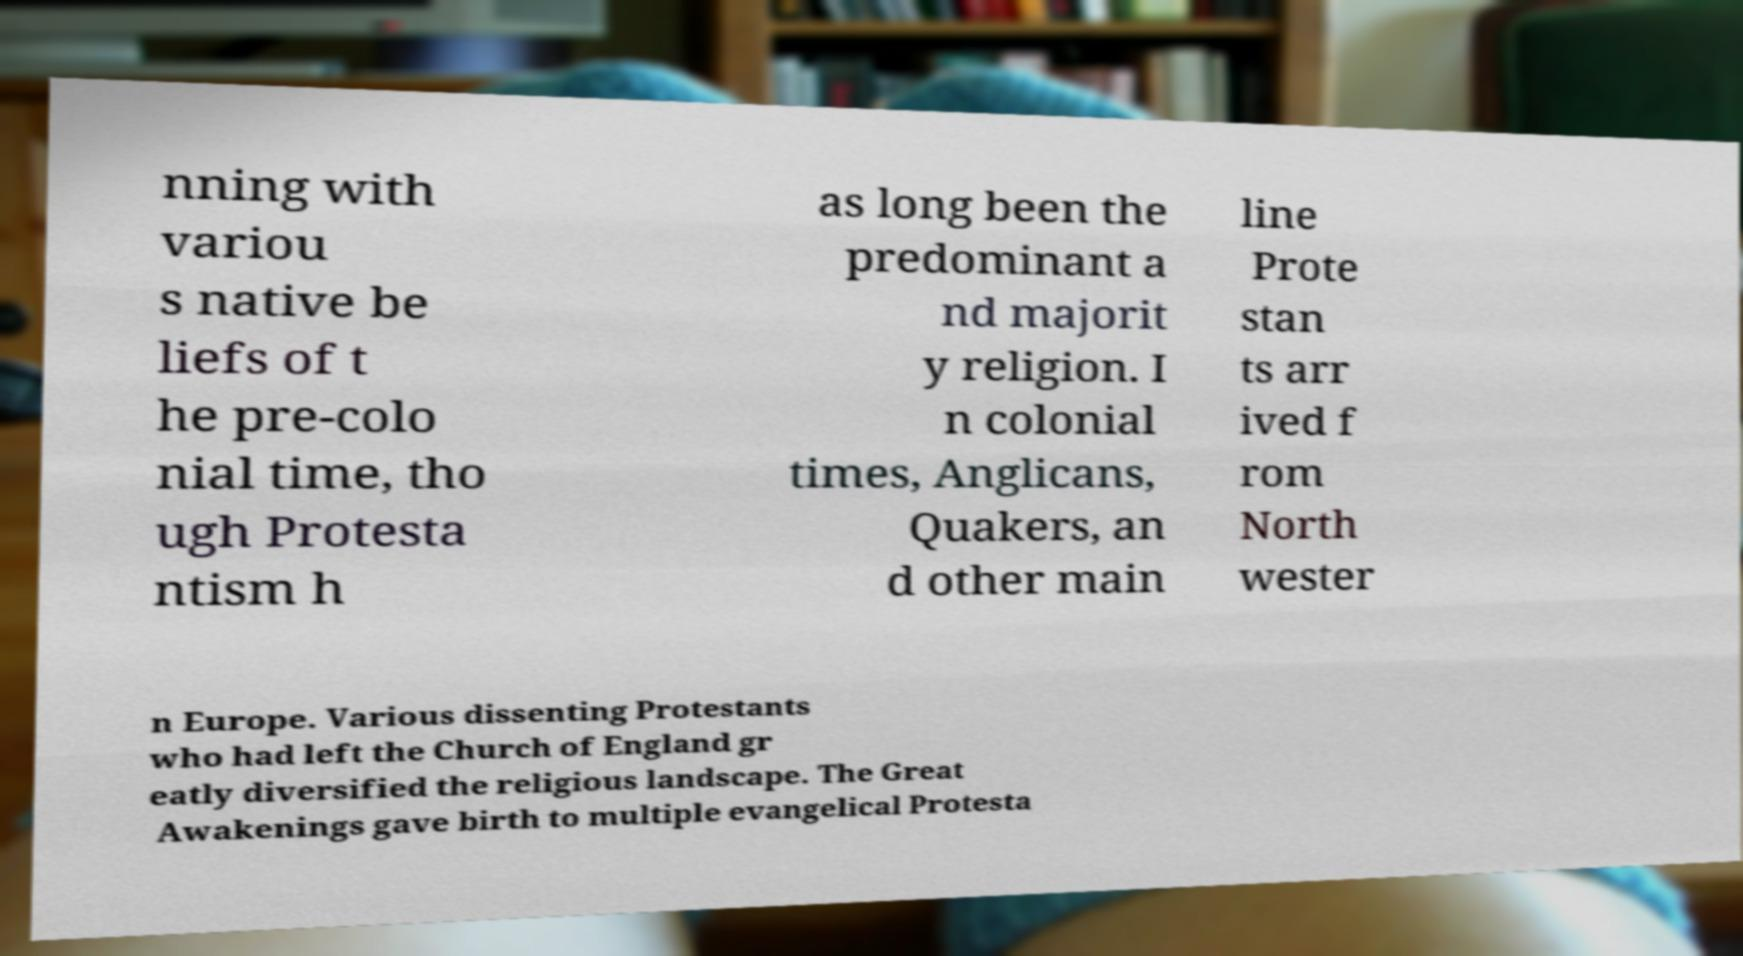There's text embedded in this image that I need extracted. Can you transcribe it verbatim? nning with variou s native be liefs of t he pre-colo nial time, tho ugh Protesta ntism h as long been the predominant a nd majorit y religion. I n colonial times, Anglicans, Quakers, an d other main line Prote stan ts arr ived f rom North wester n Europe. Various dissenting Protestants who had left the Church of England gr eatly diversified the religious landscape. The Great Awakenings gave birth to multiple evangelical Protesta 